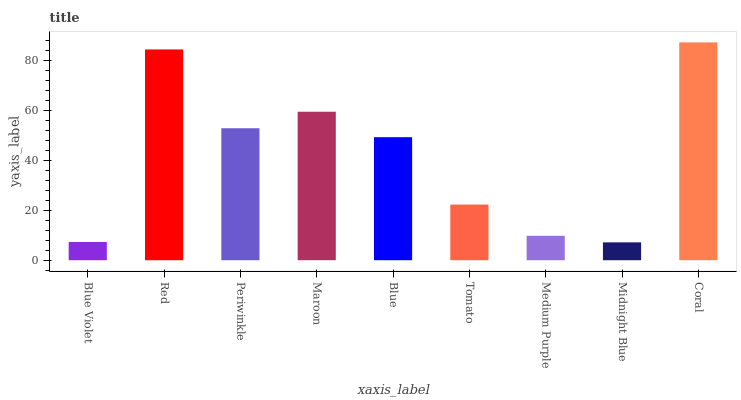Is Midnight Blue the minimum?
Answer yes or no. Yes. Is Coral the maximum?
Answer yes or no. Yes. Is Red the minimum?
Answer yes or no. No. Is Red the maximum?
Answer yes or no. No. Is Red greater than Blue Violet?
Answer yes or no. Yes. Is Blue Violet less than Red?
Answer yes or no. Yes. Is Blue Violet greater than Red?
Answer yes or no. No. Is Red less than Blue Violet?
Answer yes or no. No. Is Blue the high median?
Answer yes or no. Yes. Is Blue the low median?
Answer yes or no. Yes. Is Blue Violet the high median?
Answer yes or no. No. Is Red the low median?
Answer yes or no. No. 